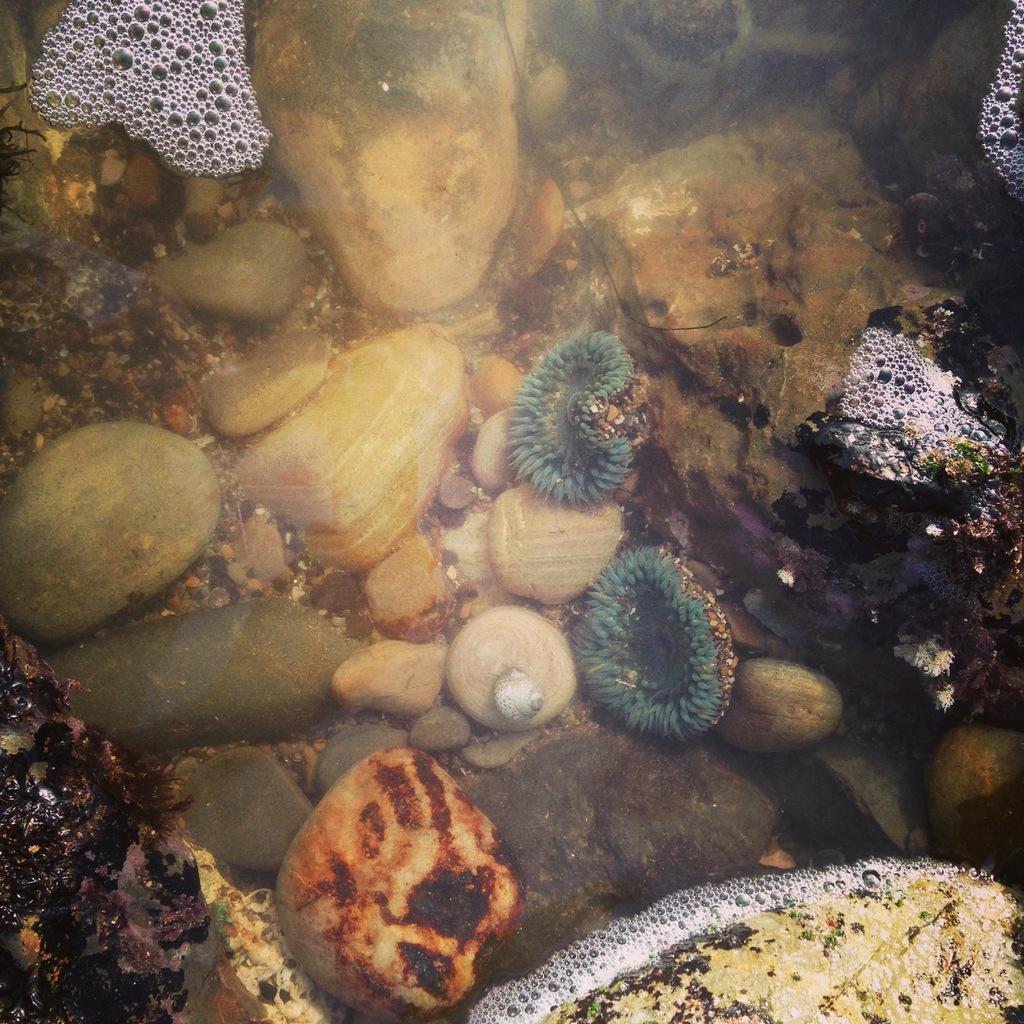In one or two sentences, can you explain what this image depicts? In this image there are so many stones and mosses under the water and also there are some bubbles with foam on the top of water. 